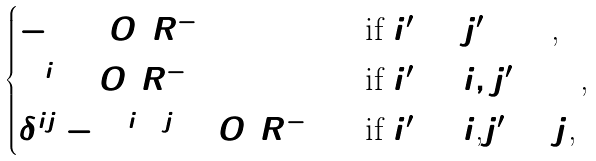<formula> <loc_0><loc_0><loc_500><loc_500>\begin{cases} - 1 + O ( R ^ { - 1 } ) & \text {if $i^{\prime}=j^{\prime}=0$,} \\ \Omega ^ { i } + O ( R ^ { - 1 } ) & \text {if $i^{\prime}=i, j^{\prime}=0$,} \\ \delta ^ { i j } - \Omega ^ { i } \Omega ^ { j } + O ( R ^ { - 1 } ) & \text {if $i^{\prime}=i$,$j^{\prime}=j$,} \end{cases}</formula> 